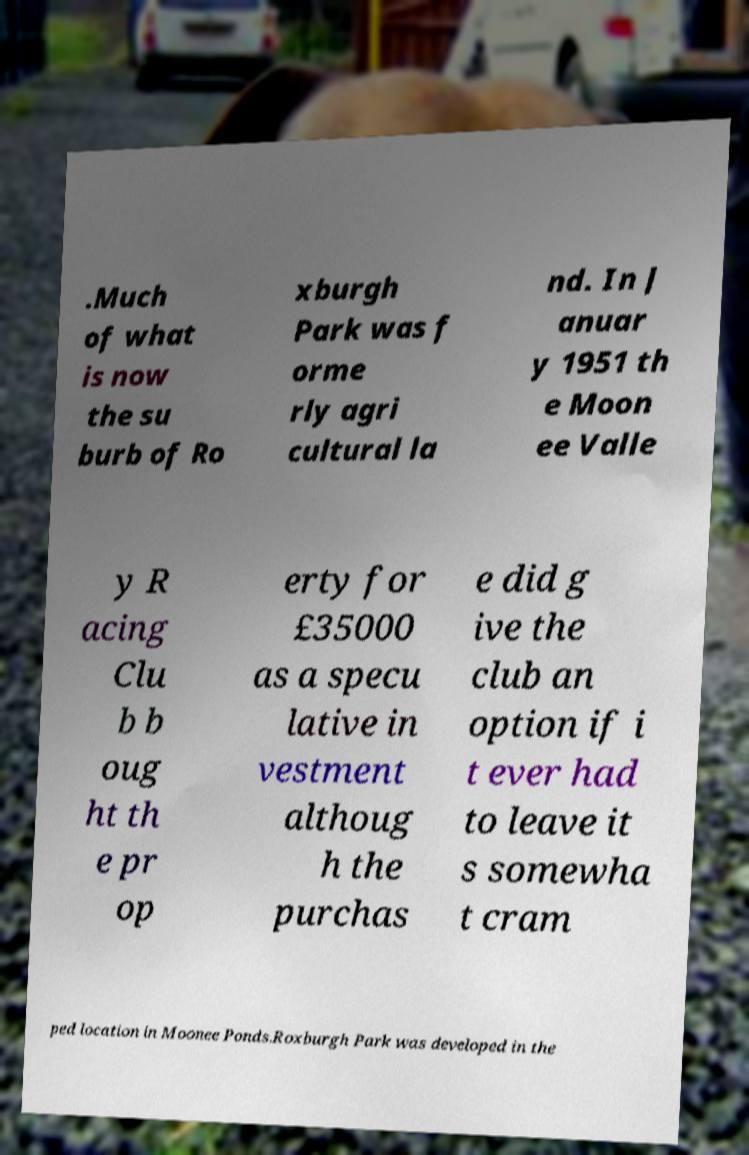Can you accurately transcribe the text from the provided image for me? .Much of what is now the su burb of Ro xburgh Park was f orme rly agri cultural la nd. In J anuar y 1951 th e Moon ee Valle y R acing Clu b b oug ht th e pr op erty for £35000 as a specu lative in vestment althoug h the purchas e did g ive the club an option if i t ever had to leave it s somewha t cram ped location in Moonee Ponds.Roxburgh Park was developed in the 